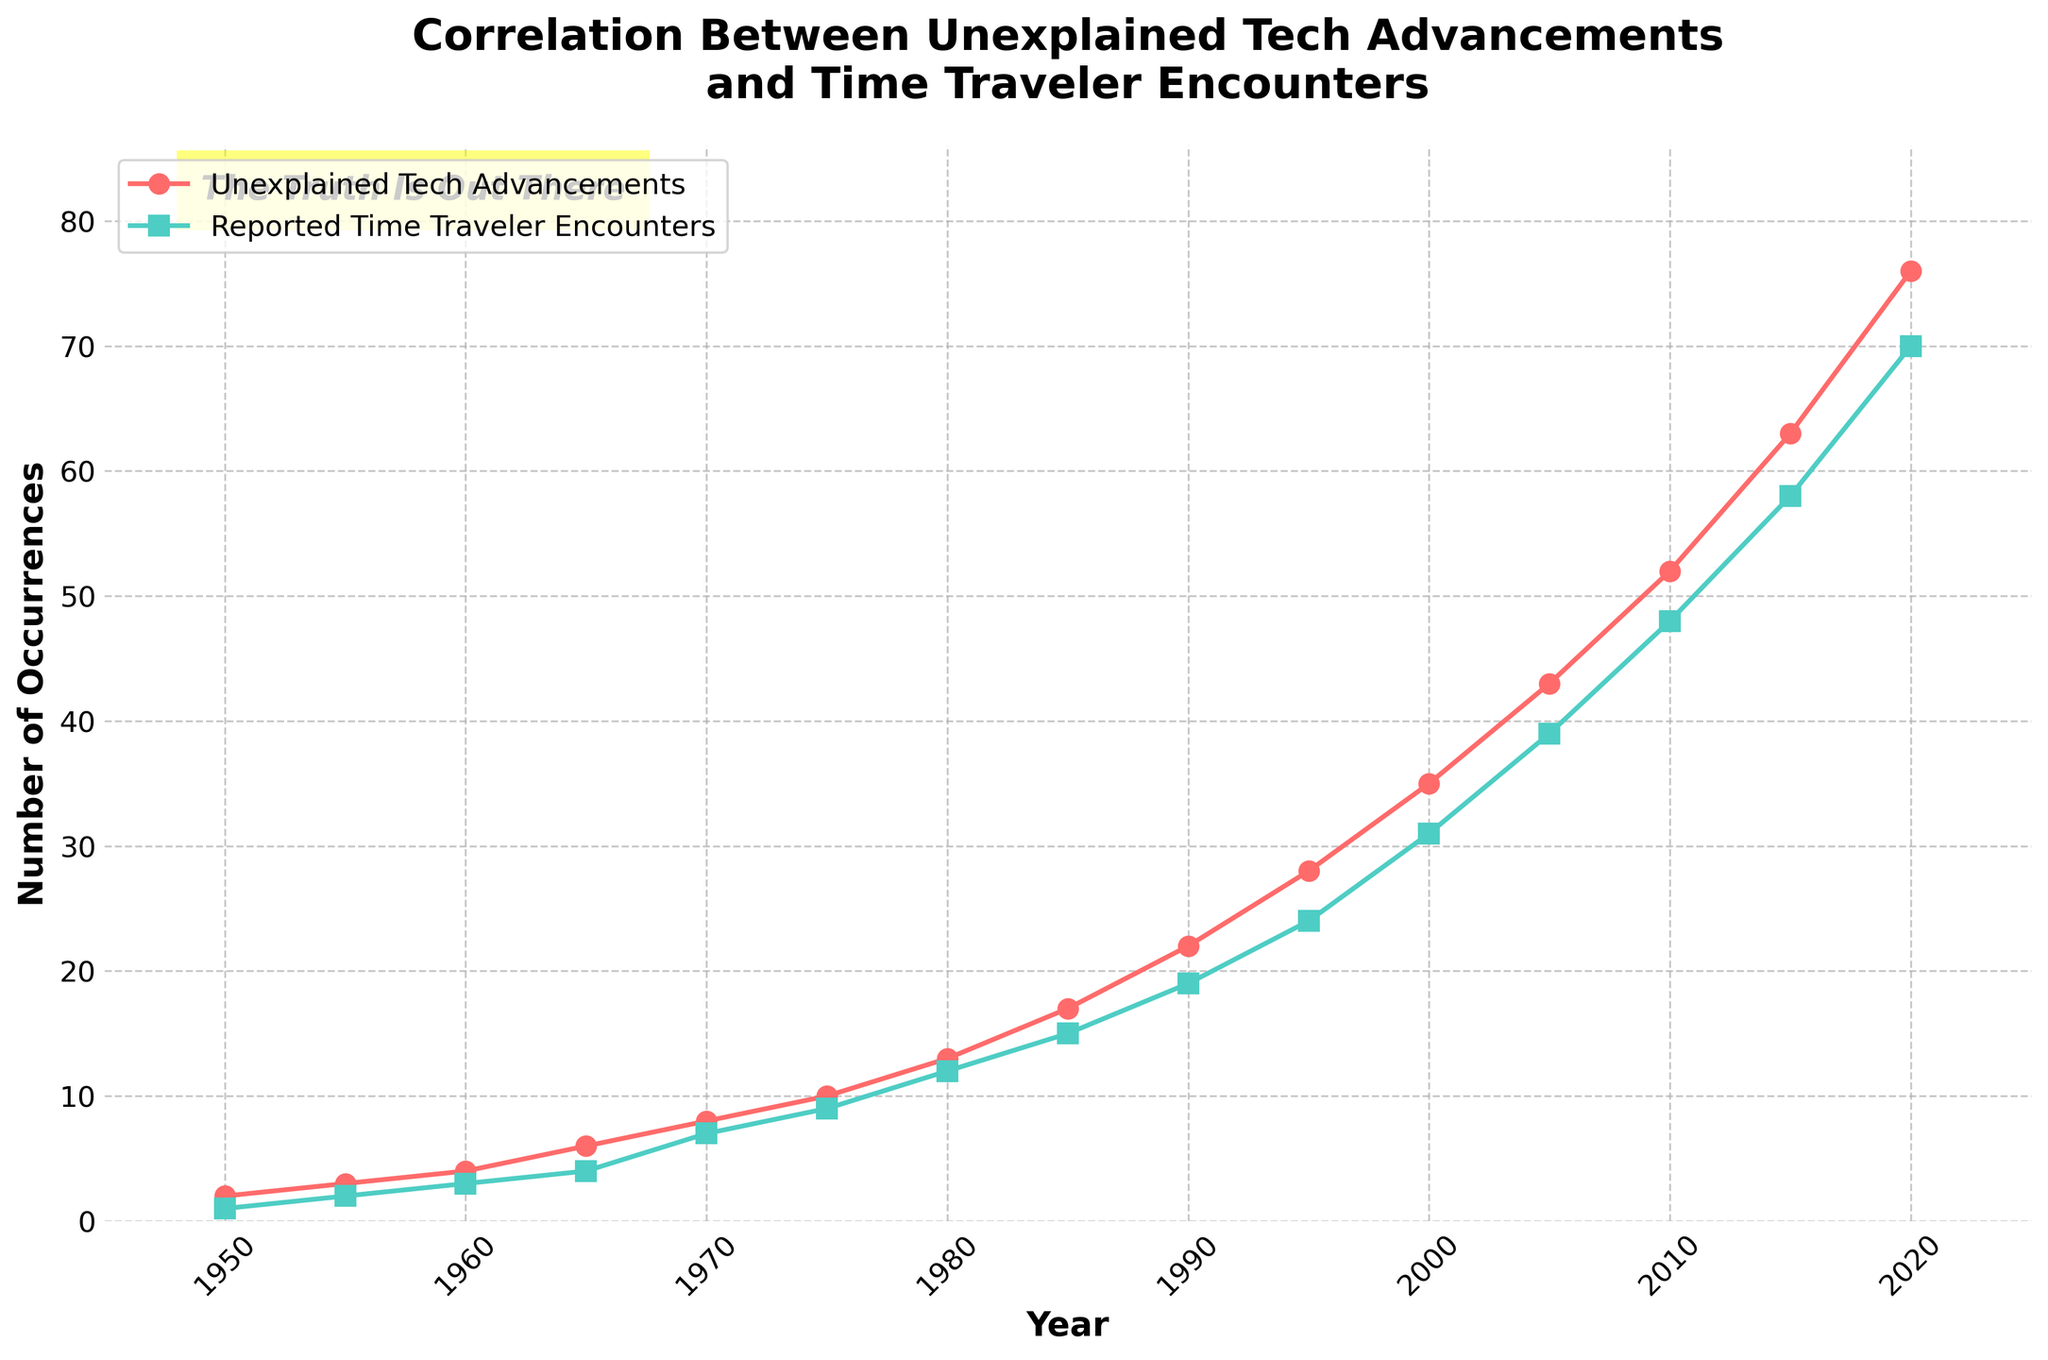What year had the biggest increase in reported time traveler encounters compared to the previous year? To find this, we need to look at year-over-year increases in reported time traveler encounters. The biggest increase is between 2000 and 2005 (from 31 to 39, so an increase of 8).
Answer: 2000 to 2005 Which year had the highest number of unexplained tech advancements? According to the plot, the year with the highest number of unexplained tech advancements is 2020.
Answer: 2020 By how much did the number of unexplained tech advancements increase from 1980 to 1990? The number of unexplained tech advancements in 1980 is 13, and in 1990 it is 22. The increase is 22 - 13 = 9.
Answer: 9 In which year did reported time traveler encounters first exceed 10? According to the plot, reported time traveler encounters first exceeded 10 in 1980.
Answer: 1980 What is the average number of reported time traveler encounters for the years 2000, 2005, and 2010? The data points for reported time traveler encounters in these years are 31, 39, and 48, respectively. Summing these gives 31 + 39 + 48 = 118. Dividing by 3 for the average, 118 / 3 ≈ 39.33.
Answer: 39.33 How does the trend in unexplained tech advancements compare to the trend in reported time traveler encounters over the entire period? Both series show an increasing trend over the period from 1950 to 2020. The trends seem to rise steadily, with a noticeable acceleration in the later years.
Answer: Both trends increase, especially accelerating in later years Which had more occurrences in 2015, unexplained tech advancements or reported time traveler encounters, and by how much? The plot shows 63 unexplained tech advancements and 58 reported time traveler encounters in 2015. 63 - 58 = 5 more unexplained tech advancements.
Answer: Unexplained tech advancements by 5 From 1960 to 1970, what was the increase in the number of unexplained tech advancements, and how does it compare to the increase in reported time traveler encounters over the same period? The number of unexplained tech advancements increased from 4 to 8 (an increase of 4), while reported time traveler encounters increased from 3 to 7 (an increase of 4). Both increased by the same amount (4).
Answer: Both increased by 4 